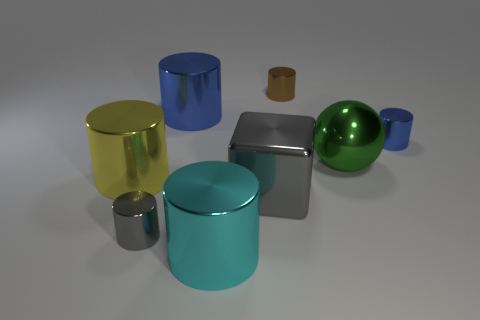Is the number of brown shiny things in front of the yellow metallic thing greater than the number of spheres that are in front of the tiny gray thing?
Offer a very short reply. No. There is a small gray metal object; are there any large shiny balls in front of it?
Offer a very short reply. No. There is a big cylinder that is behind the small gray cylinder and right of the large yellow thing; what material is it?
Keep it short and to the point. Metal. There is a metal cylinder that is to the right of the large green shiny thing; are there any big metallic things behind it?
Provide a short and direct response. Yes. What size is the brown cylinder?
Offer a very short reply. Small. The shiny thing that is behind the gray metal cube and in front of the green thing has what shape?
Make the answer very short. Cylinder. How many brown things are shiny blocks or large metallic things?
Your response must be concise. 0. There is a blue cylinder on the right side of the large cyan cylinder; does it have the same size as the blue metal object on the left side of the tiny brown cylinder?
Your response must be concise. No. How many things are brown matte things or gray cylinders?
Your response must be concise. 1. Is there a large cyan object that has the same shape as the small gray metal object?
Provide a short and direct response. Yes. 